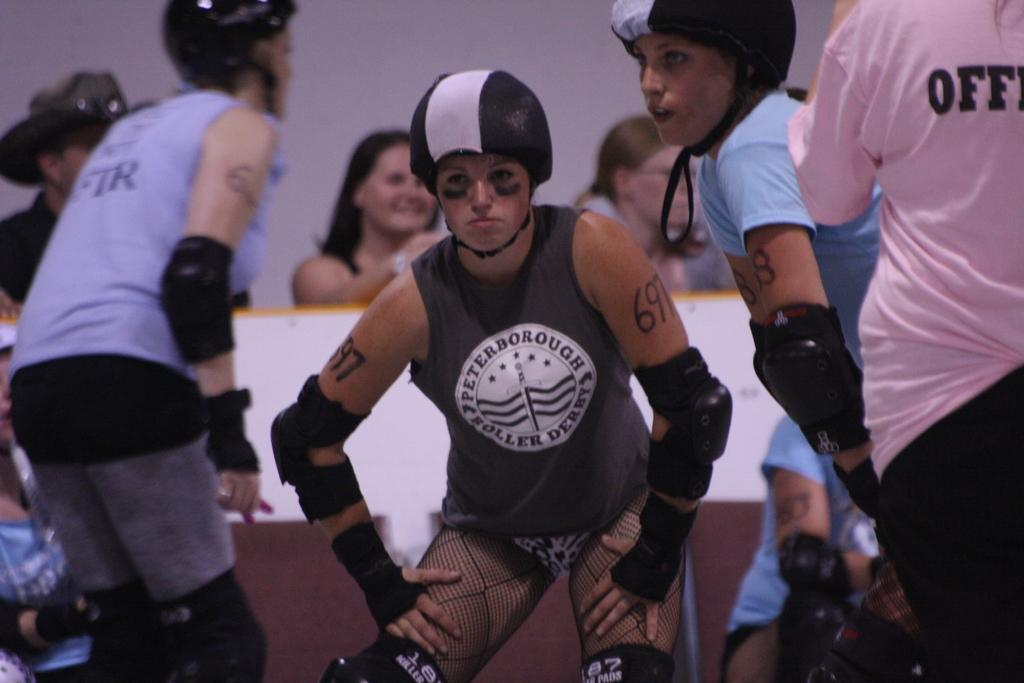What is happening in the front of the image? There is a group of people standing in the front of the image. What can be seen in the background of the image? There is a wall in the background of the image. What theory is being discussed by the committee in the image? There is no committee present in the image, and therefore no discussion of a theory can be observed. Can you see anyone taking a bite of food in the image? There is no indication of anyone eating or taking a bite of food in the image. 